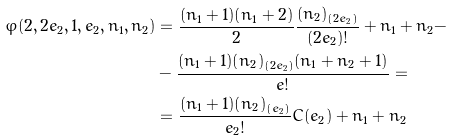Convert formula to latex. <formula><loc_0><loc_0><loc_500><loc_500>\varphi ( 2 , 2 e _ { 2 } , 1 , e _ { 2 } , n _ { 1 } , n _ { 2 } ) & = \frac { ( n _ { 1 } + 1 ) ( n _ { 1 } + 2 ) } { 2 } \frac { ( n _ { 2 } ) _ { ( 2 e _ { 2 } ) } } { ( 2 e _ { 2 } ) ! } + n _ { 1 } + n _ { 2 } - \\ & - \frac { ( n _ { 1 } + 1 ) ( n _ { 2 } ) _ { ( 2 e _ { 2 } ) } ( n _ { 1 } + n _ { 2 } + 1 ) } { e ! } = \\ & = \frac { ( n _ { 1 } + 1 ) ( n _ { 2 } ) _ { ( e _ { 2 } ) } } { e _ { 2 } ! } C ( e _ { 2 } ) + n _ { 1 } + n _ { 2 }</formula> 